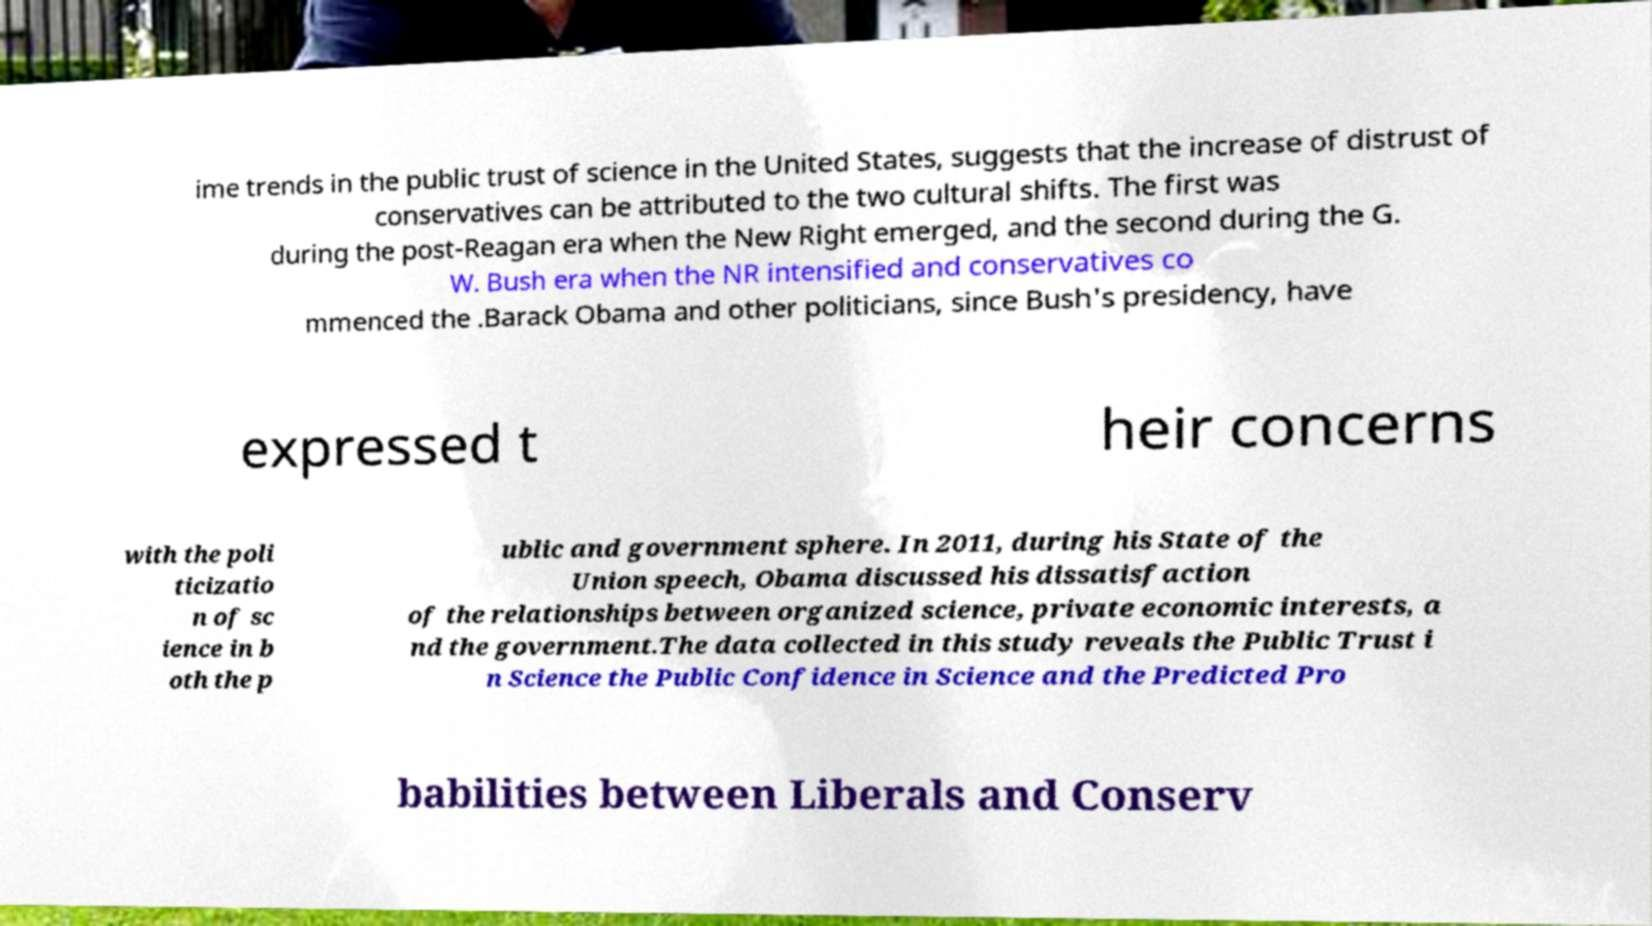Please identify and transcribe the text found in this image. ime trends in the public trust of science in the United States, suggests that the increase of distrust of conservatives can be attributed to the two cultural shifts. The first was during the post-Reagan era when the New Right emerged, and the second during the G. W. Bush era when the NR intensified and conservatives co mmenced the .Barack Obama and other politicians, since Bush's presidency, have expressed t heir concerns with the poli ticizatio n of sc ience in b oth the p ublic and government sphere. In 2011, during his State of the Union speech, Obama discussed his dissatisfaction of the relationships between organized science, private economic interests, a nd the government.The data collected in this study reveals the Public Trust i n Science the Public Confidence in Science and the Predicted Pro babilities between Liberals and Conserv 